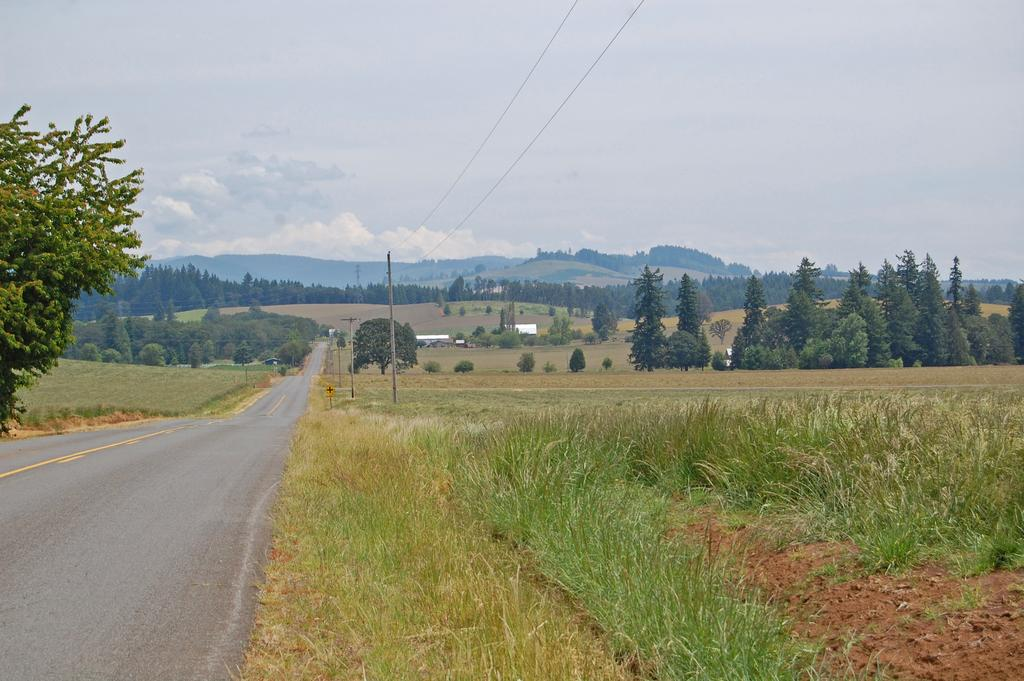What is the main feature of the image? There is a road in the image. What can be seen on the right side of the road? There are electric poles with cables, grass, and trees on the right side of the road. What is the terrain like in front of the road? There are hills in front of the road. How would you describe the sky in the image? The sky is cloudy in the image. Where is the shelf located in the image? There is no shelf present in the image. How are the items on the road being sorted in the image? There are no items being sorted on the road in the image. 